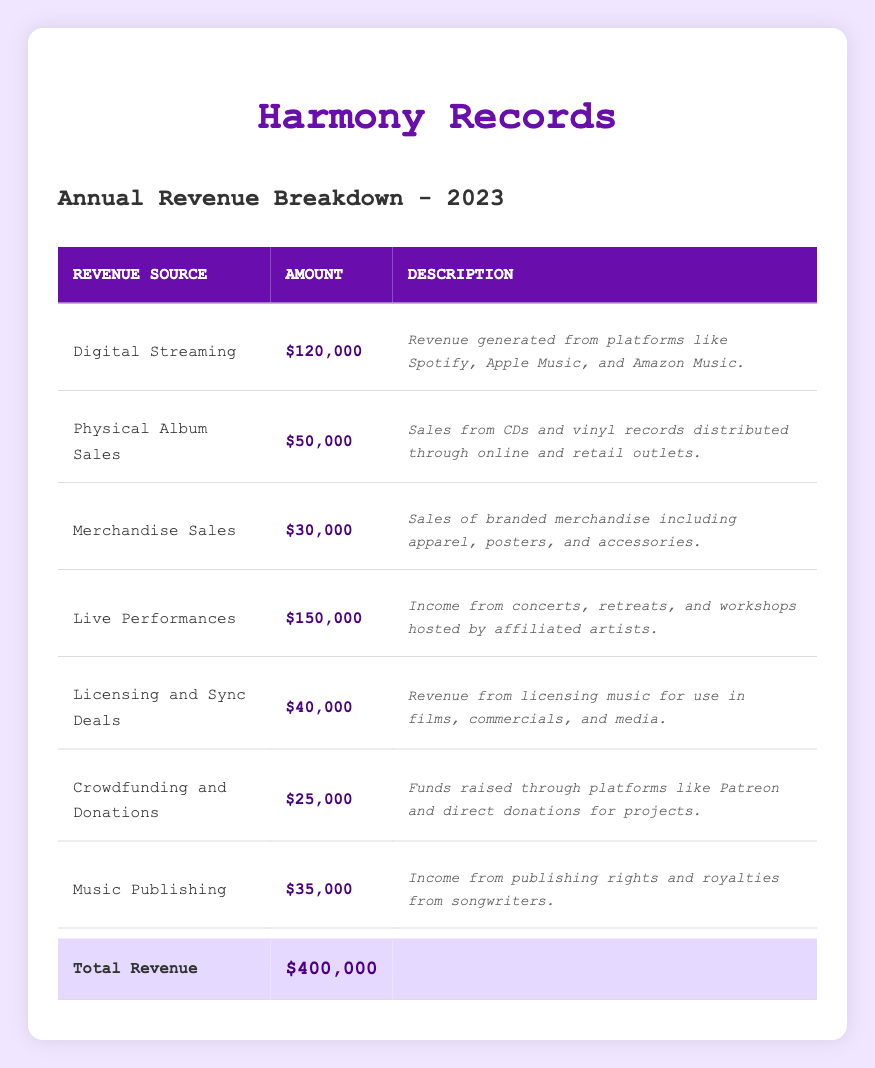What is the revenue from Digital Streaming? The specific row for Digital Streaming shows an amount of $120,000.
Answer: $120,000 How much revenue is generated from Live Performances? According to the table, the amount listed for Live Performances is $150,000.
Answer: $150,000 What is the total revenue from all sources? The total revenue is explicitly stated in the last row of the table, which is $400,000.
Answer: $400,000 Is the revenue from Merchandise Sales greater than that from Crowdfunding and Donations? Merchandise Sales amount to $30,000, while Crowdfunding and Donations amount to $25,000. Since $30,000 > $25,000, the statement is true.
Answer: Yes What is the difference in revenue between Digital Streaming and Physical Album Sales? The revenue from Digital Streaming is $120,000 and from Physical Album Sales it's $50,000. The difference is calculated as $120,000 - $50,000 = $70,000.
Answer: $70,000 Calculate the percentage of total revenue that comes from Live Performances. Live Performances generate $150,000. To find the percentage, divide $150,000 by the total revenue of $400,000 and multiply by 100: ($150,000 / $400,000) * 100 = 37.5%.
Answer: 37.5% How does revenue from Physical Album Sales compare to the total revenue? Physical Album Sales contribute $50,000 to the total revenue of $400,000. To find the comparison, (50,000 / 400,000) * 100 = 12.5%, showing that it makes up 12.5% of the total.
Answer: 12.5% What is the total revenue from all sources except for Merchandise Sales? To find this, subtract the revenue from Merchandise Sales, which is $30,000, from the total revenue, $400,000. Thus, $400,000 - $30,000 = $370,000.
Answer: $370,000 If you combine revenue from Licensing and Sync Deals and Music Publishing, what is the total? Licensing and Sync Deals bring in $40,000, and Music Publishing brings in $35,000. Adding these gives $40,000 + $35,000 = $75,000.
Answer: $75,000 Is Digital Streaming the highest revenue source for Harmony Records? The highest revenue source is Live Performances at $150,000, which is greater than Digital Streaming's revenue of $120,000. Therefore, Digital Streaming is not the highest source.
Answer: No 